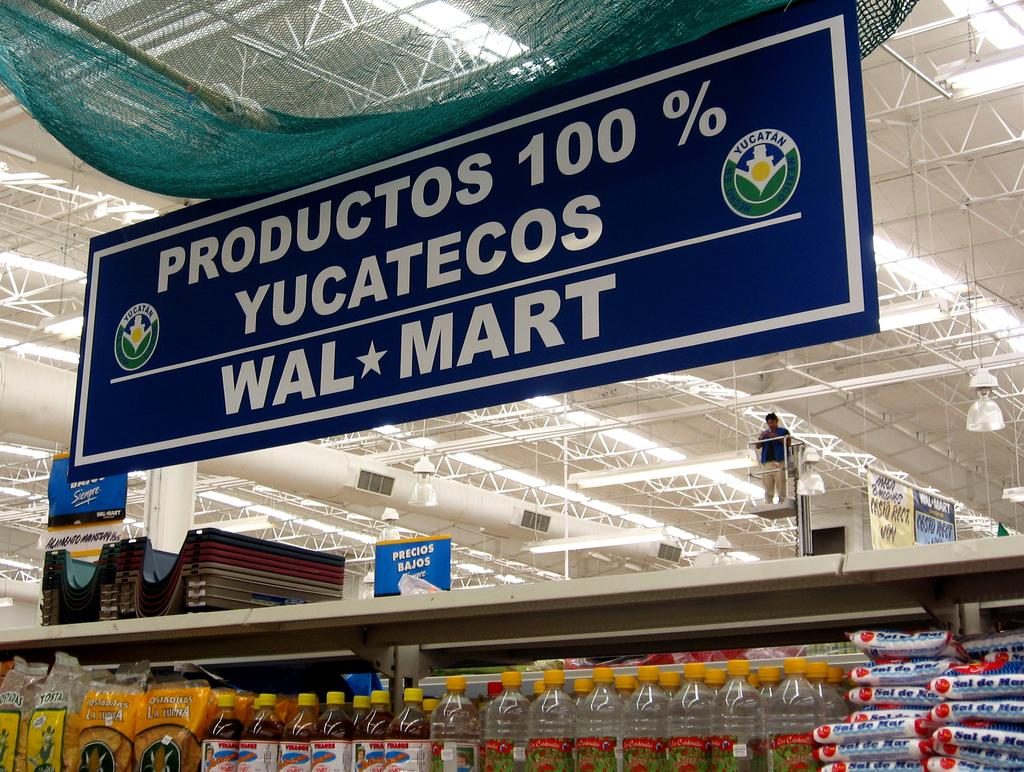<image>
Provide a brief description of the given image. A Walmart sign above an aisle in a store. 